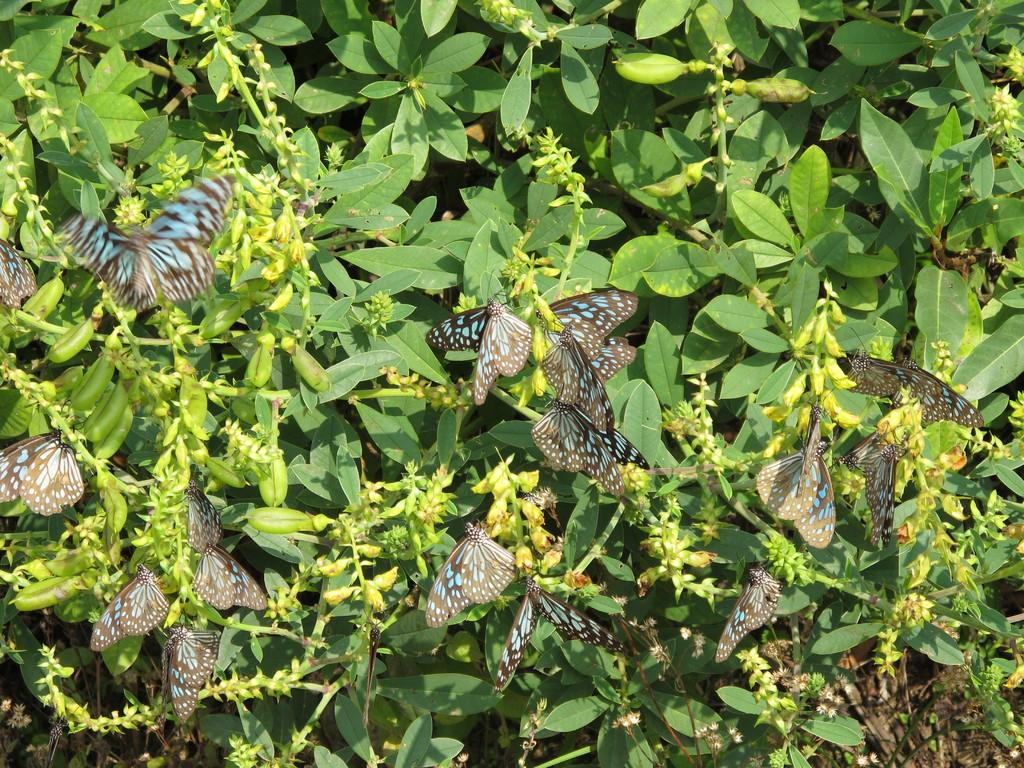What type of living organisms can be seen in the image? Insects can be seen in the image. What type of plant material is present in the image? Leaves can be seen in the image. What type of beds can be seen in the image? There are no beds present in the image. How many toes are visible in the image? There are no toes visible in the image. 